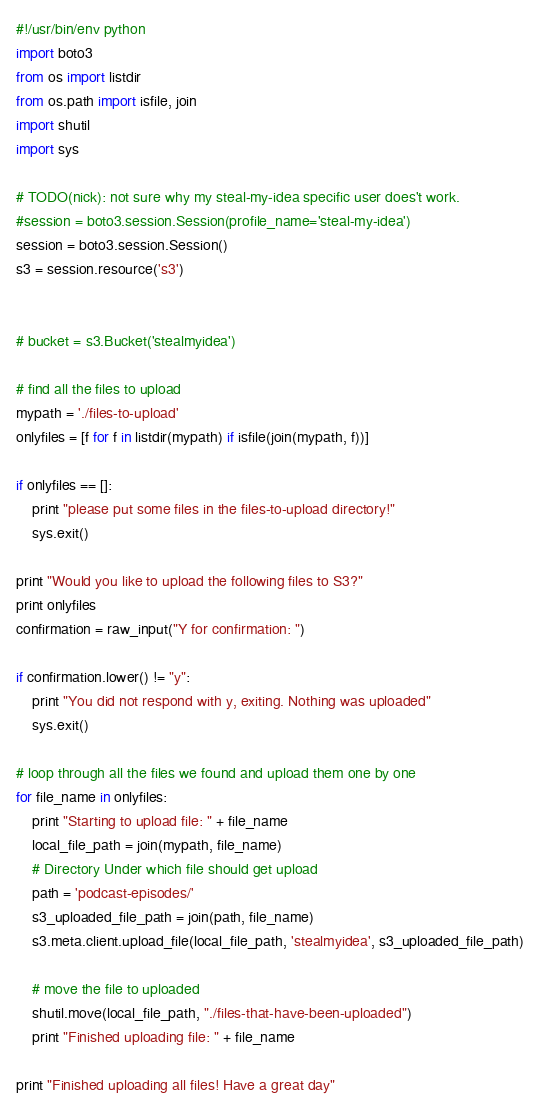<code> <loc_0><loc_0><loc_500><loc_500><_Python_>#!/usr/bin/env python
import boto3
from os import listdir
from os.path import isfile, join
import shutil
import sys

# TODO(nick): not sure why my steal-my-idea specific user does't work. 
#session = boto3.session.Session(profile_name='steal-my-idea')
session = boto3.session.Session()
s3 = session.resource('s3')


# bucket = s3.Bucket('stealmyidea')

# find all the files to upload
mypath = './files-to-upload'
onlyfiles = [f for f in listdir(mypath) if isfile(join(mypath, f))]

if onlyfiles == []:
	print "please put some files in the files-to-upload directory!"
	sys.exit()

print "Would you like to upload the following files to S3?"
print onlyfiles
confirmation = raw_input("Y for confirmation: ")

if confirmation.lower() != "y": 
	print "You did not respond with y, exiting. Nothing was uploaded"
	sys.exit()

# loop through all the files we found and upload them one by one
for file_name in onlyfiles:
	print "Starting to upload file: " + file_name
	local_file_path = join(mypath, file_name)
	# Directory Under which file should get upload
	path = 'podcast-episodes/' 
	s3_uploaded_file_path = join(path, file_name)
	s3.meta.client.upload_file(local_file_path, 'stealmyidea', s3_uploaded_file_path)

	# move the file to uploaded
	shutil.move(local_file_path, "./files-that-have-been-uploaded")
	print "Finished uploading file: " + file_name

print "Finished uploading all files! Have a great day"</code> 